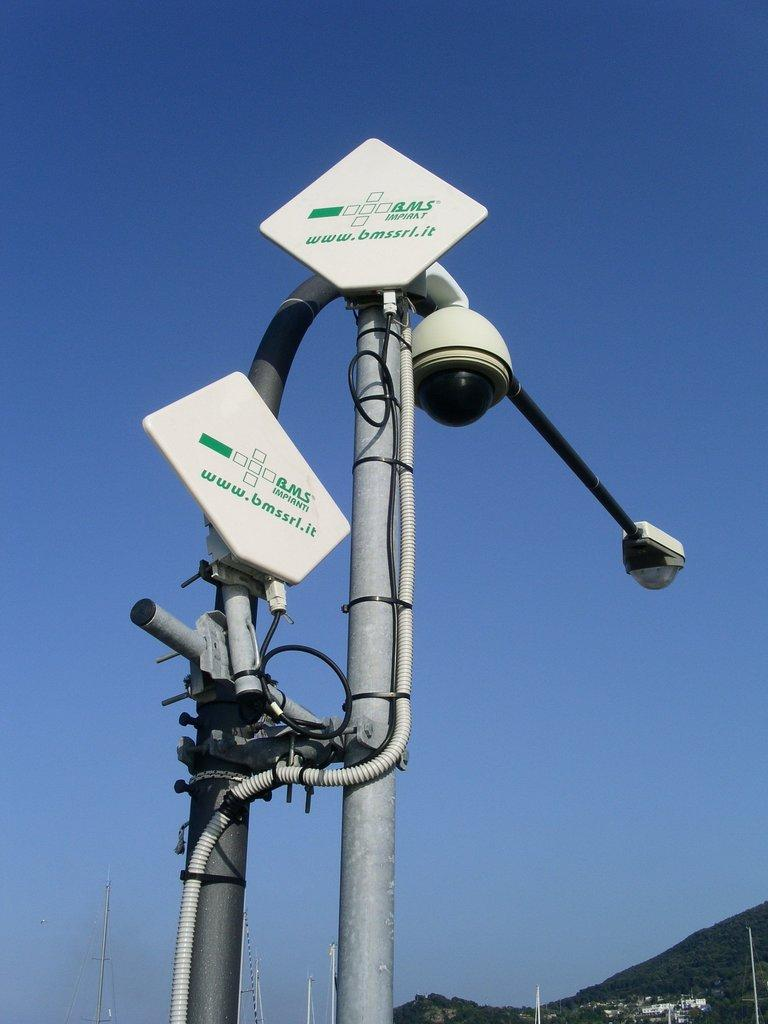What is the main object in the image? There is a pole in the image. What is attached to the pole? There are two white color boards on the pole. Is there any lighting equipment on the pole? Yes, there is a light fixed to the pole. What can be seen in the background of the image? The sky is visible in the background of the image. What type of dinner is being served on the pole in the image? There is no dinner being served on the pole in the image; it features a pole with two white color boards and a light. How many men are visible on the pole in the image? There are no men present on the pole in the image. 